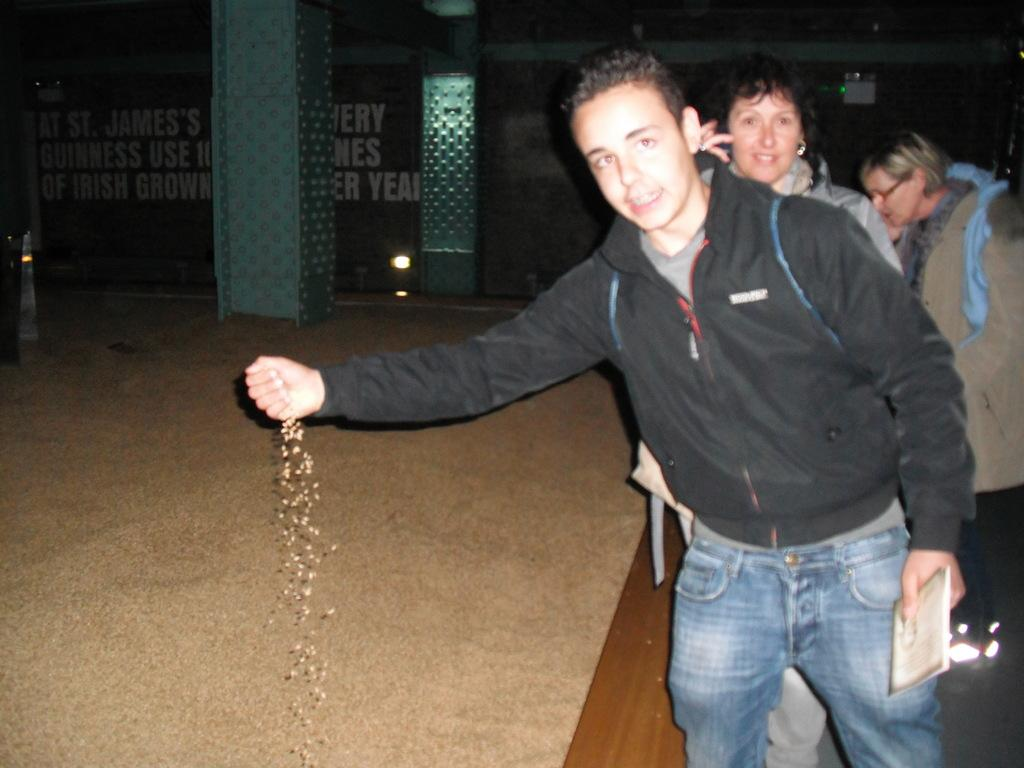How many people are present in the image? There are three persons in the image. What is one person holding in the image? One person is holding a book. What type of surface is visible in the image? The image shows a floor. What architectural features can be seen in the background of the image? There are pillars and a wall in the background of the image. What type of illumination is present in the background of the image? There are lights in the background of the image. What type of toys can be seen on the floor in the image? There are no toys visible on the floor in the image. What advice might the grandfather give to the person holding the book in the image? There is no grandfather present in the image, so it is not possible to determine what advice he might give. 